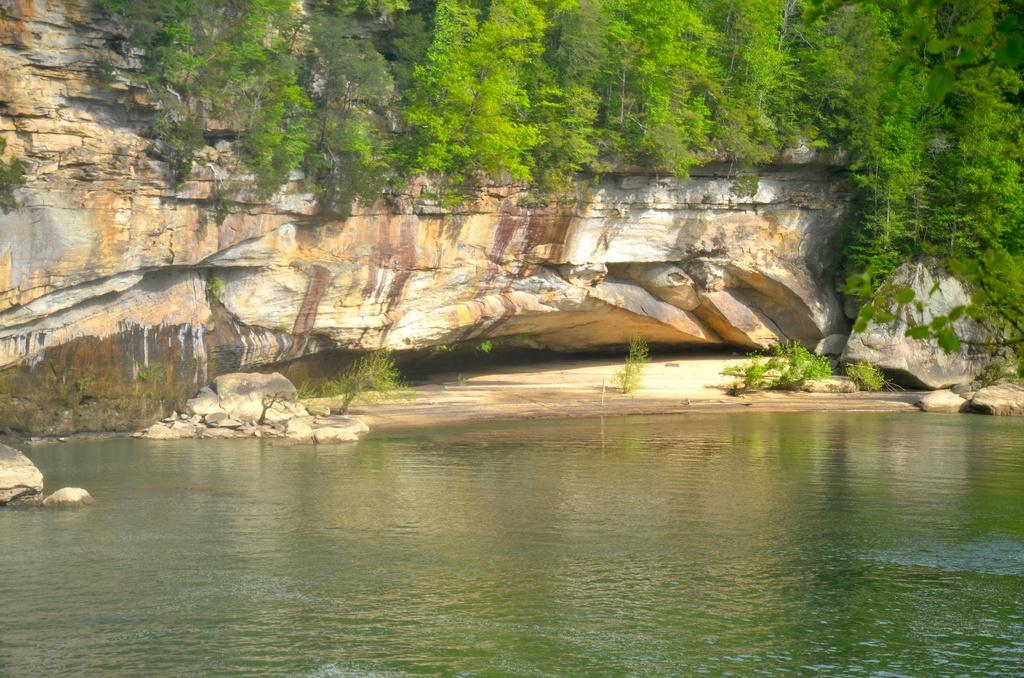What is visible in the image? Water is visible in the image. What can be seen in the background of the image? There are plants and trees in the background of the image. Where are the trees located in relation to the hill? The trees are on a hill. What type of theory can be seen being tested in the image? There is no theory being tested in the image; it features water, plants, trees, and a hill. Can you see any rays of light in the image? There is no mention of rays of light in the image; it only features water, plants, trees, and a hill. 